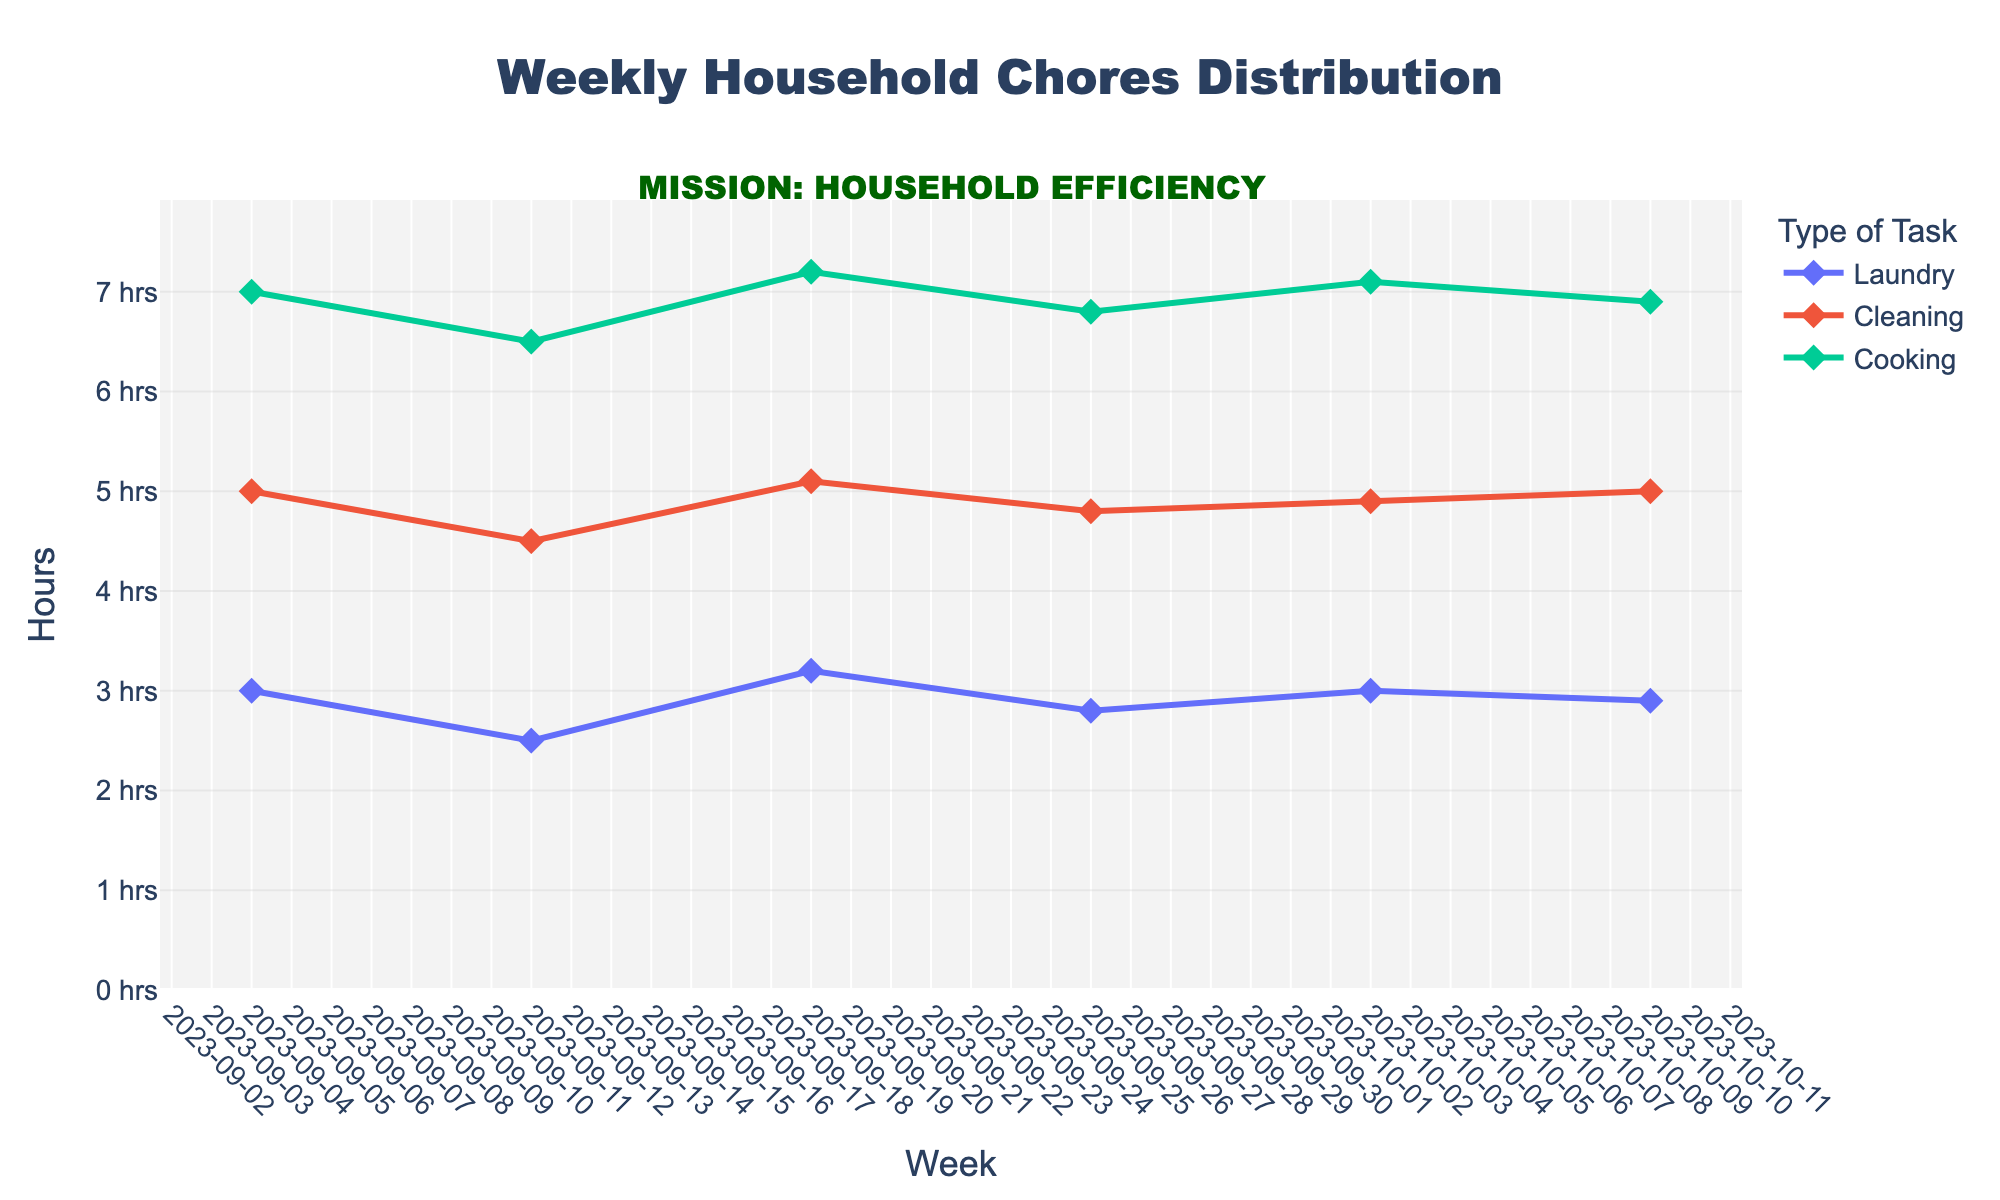What is the title of the figure? The title is located at the top of the chart, indicating what the figure represents.
Answer: Weekly Household Chores Distribution Which task took the most hours in the week of 2023-09-04? Look at the data points for the week of 2023-09-04 and identify the task with the highest value on the y-axis.
Answer: Cooking How many hours were spent on Laundry in the week of 2023-09-25? Review the Laundry data point for the week of 2023-09-25 to find the corresponding y-axis value.
Answer: 2.8 What was the average time spent on Cooking from 2023-09-04 to 2023-10-09? Sum the hours spent on Cooking for each week from 2023-09-04 to 2023-10-09 and then divide by the number of weeks. (7 + 6.5 + 7.2 + 6.8 + 7.1 + 6.9) / 6 = 6.75
Answer: 6.75 Which task had the least variation in hours spent over the 6 weeks? Compare the range (max value - min value) of hours spent on each task over the 6 weeks and identify the task with the smallest range. Laundry: 3.2 - 2.5 = 0.7, Cleaning: 5.1 - 4.5 = 0.6, Cooking: 7.2 - 6.5 = 0.7
Answer: Cleaning Was there any week where the time spent on Cleaning was exactly 5 hours? Check the Cleaning data points for each week to find if any of them have a y-axis value of exactly 5 hours.
Answer: Yes, on 2023-10-09 Between which weeks did the hours spent on Laundry increase the most? Calculate the differences in hours spent on Laundry between consecutive weeks and identify the largest increment. 2023-09-11 to 2023-09-18 (0.7)
Answer: 2023-09-11 to 2023-09-18 Which task shows a consistent weekly pattern over the given period? Analyze the trend lines for each task and identify the one with the least fluctuation.
Answer: Cooking How many data points are there for each task? Count the number of data points (weeks) for one task and confirm it is consistent across all tasks.
Answer: 6 By how much did the Cleaning hours increase from the week of 2023-09-11 to the week of 2023-10-02? Subtract the Cleaning hours for 2023-09-11 from those in 2023-10-02. 4.9 - 4.5 = 0.4
Answer: 0.4 